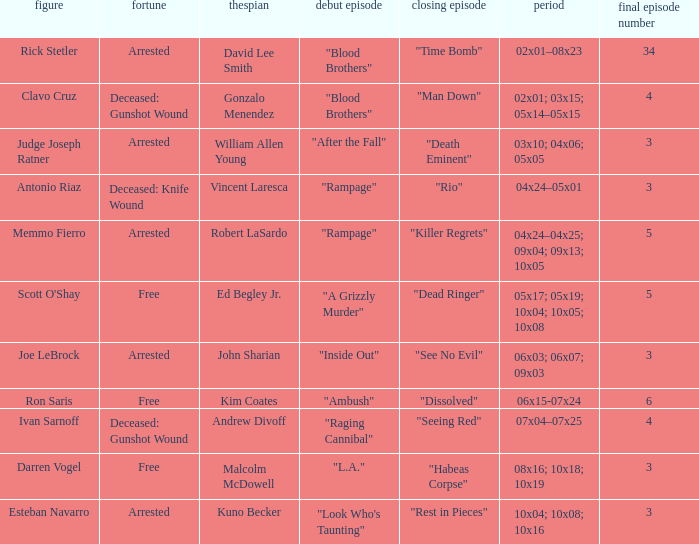What's the character with fate being deceased: knife wound Antonio Riaz. 